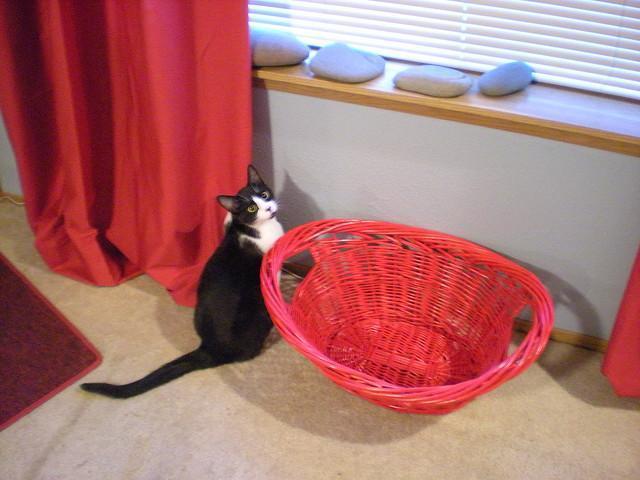How many objects are on the windowsill?
Give a very brief answer. 4. How many images of the man are black and white?
Give a very brief answer. 0. 